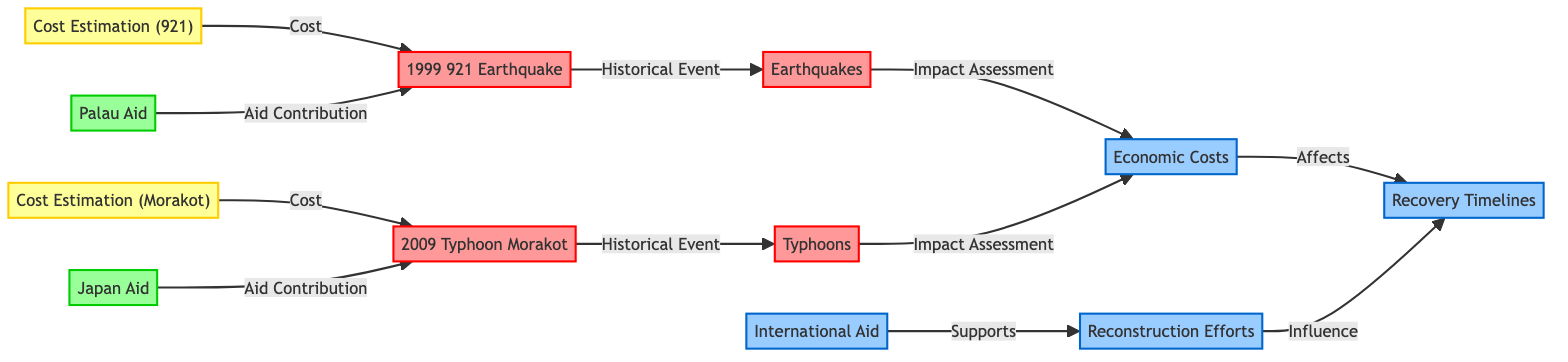What are the two main types of natural disasters represented in the diagram? The diagram shows "Earthquakes" and "Typhoons" as the two main categories of natural disasters affecting Taiwan. These are the two key nodes categorized under disasters, thus we identify these two as the main types.
Answer: Earthquakes, Typhoons What is the historical event associated with the economic costs of the 921 Earthquake? The node for "921 Earthquake" is connected to the node "Earthquakes" through the relationship "Historical Event", which implies that the 921 Earthquake falls under the broader category of earthquakes.
Answer: Earthquakes Which aid contributions are tied to the Morakot Typhoon? The diagram links "Japan Aid" directly to "Morakot Typhoon" with the relationship "Aid Contribution", indicating this specific aid contribution is associated with the reconstruction efforts related to the Morakot Typhoon.
Answer: Japan Aid How many nodes represent economic costs in the diagram? The economic costs are represented by only one node, labeled "Economic Costs". This node stands alone in its category, meaning there is a single focus point in the diagram for this concept.
Answer: 1 Which node influences recovery timelines in the diagram? Both "Economic Costs" and "Reconstruction Efforts" are nodes that have a direct relationship affecting "Recovery Timelines". This means we see two nodes influencing the recovery process following natural disasters in Taiwan.
Answer: Economic Costs, Reconstruction Efforts What is the relationship between international aid and reconstruction efforts? The diagram indicates that "International Aid" supports "Reconstruction Efforts", establishing a clear relationship that signifies how international aid plays a role in recovery after natural disasters.
Answer: Supports Which economic costs are estimated for the 921 Earthquake and Morakot Typhoon? The diagram includes nodes labeled "Cost Estimation (921)" for the 921 Earthquake and "Cost Estimation (Morakot)" for the Morakot Typhoon, clearly linking these estimations to their respective disasters.
Answer: Cost Estimation (921), Cost Estimation (Morakot) What is the structure type of the diagram? The diagram is structured as a flowchart, showing various interconnected nodes that represent relationships between economic costs, recovery timelines, reconstruction efforts, and international aid regarding natural disasters.
Answer: Flowchart 